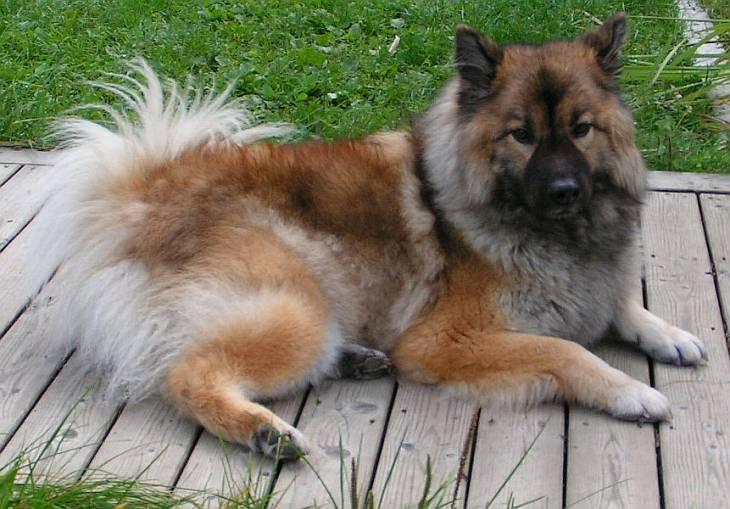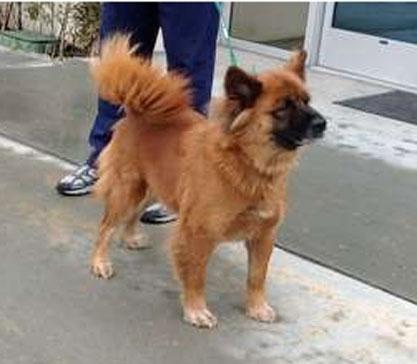The first image is the image on the left, the second image is the image on the right. Considering the images on both sides, is "In one image a dog is lying down on a raised surface." valid? Answer yes or no. Yes. The first image is the image on the left, the second image is the image on the right. Analyze the images presented: Is the assertion "At least one of the dogs is indoors." valid? Answer yes or no. No. 